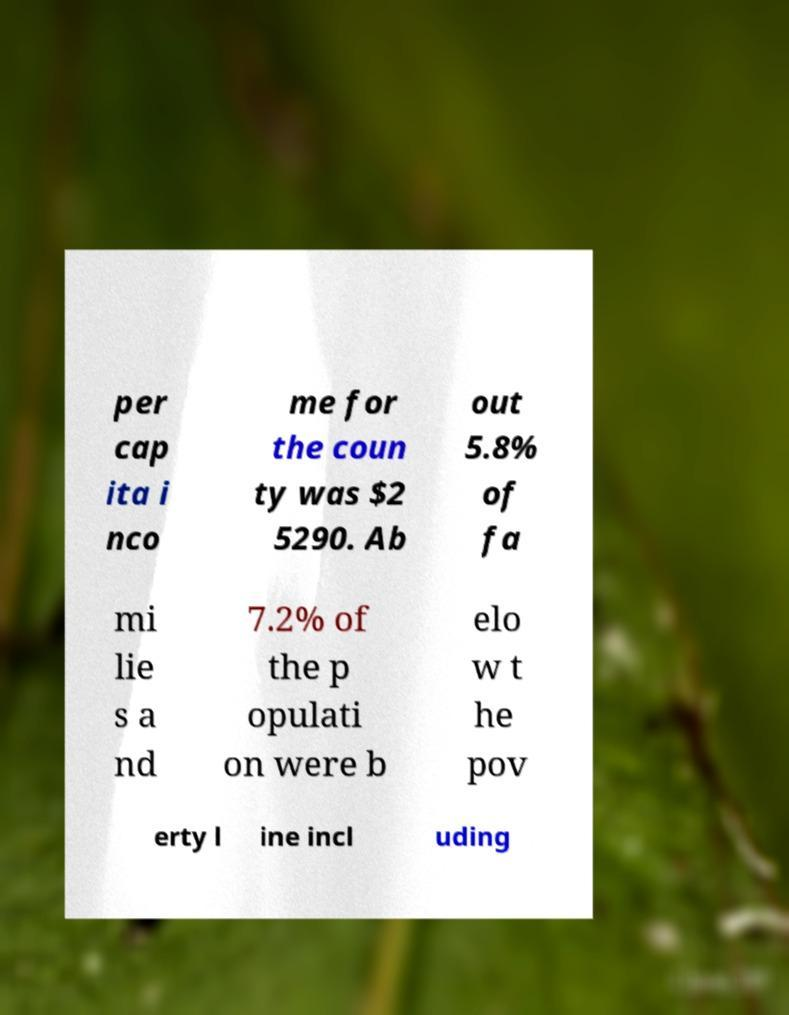For documentation purposes, I need the text within this image transcribed. Could you provide that? per cap ita i nco me for the coun ty was $2 5290. Ab out 5.8% of fa mi lie s a nd 7.2% of the p opulati on were b elo w t he pov erty l ine incl uding 